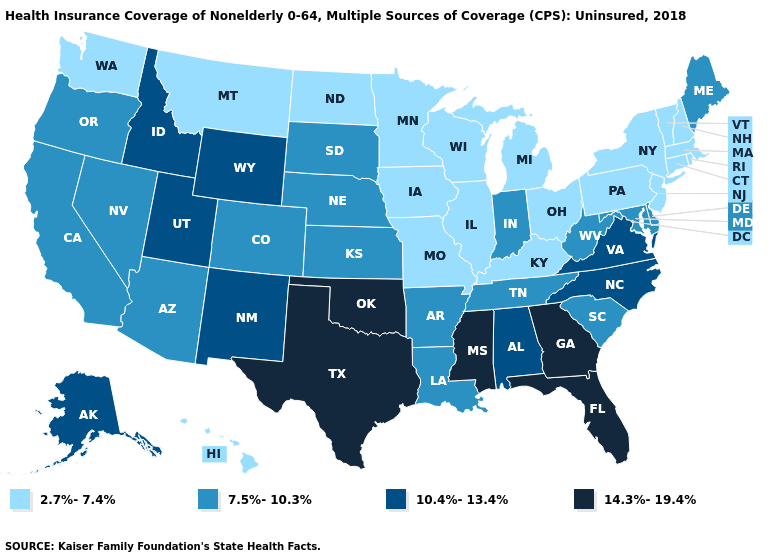What is the value of Rhode Island?
Concise answer only. 2.7%-7.4%. Among the states that border North Carolina , which have the lowest value?
Write a very short answer. South Carolina, Tennessee. Name the states that have a value in the range 2.7%-7.4%?
Answer briefly. Connecticut, Hawaii, Illinois, Iowa, Kentucky, Massachusetts, Michigan, Minnesota, Missouri, Montana, New Hampshire, New Jersey, New York, North Dakota, Ohio, Pennsylvania, Rhode Island, Vermont, Washington, Wisconsin. Does Arizona have the same value as Kansas?
Short answer required. Yes. Does Rhode Island have the lowest value in the USA?
Write a very short answer. Yes. Among the states that border Vermont , which have the lowest value?
Give a very brief answer. Massachusetts, New Hampshire, New York. What is the lowest value in states that border Massachusetts?
Short answer required. 2.7%-7.4%. Among the states that border Oklahoma , which have the lowest value?
Concise answer only. Missouri. What is the value of Ohio?
Be succinct. 2.7%-7.4%. What is the highest value in states that border Delaware?
Short answer required. 7.5%-10.3%. Which states have the lowest value in the USA?
Concise answer only. Connecticut, Hawaii, Illinois, Iowa, Kentucky, Massachusetts, Michigan, Minnesota, Missouri, Montana, New Hampshire, New Jersey, New York, North Dakota, Ohio, Pennsylvania, Rhode Island, Vermont, Washington, Wisconsin. Among the states that border West Virginia , which have the highest value?
Quick response, please. Virginia. Name the states that have a value in the range 10.4%-13.4%?
Be succinct. Alabama, Alaska, Idaho, New Mexico, North Carolina, Utah, Virginia, Wyoming. How many symbols are there in the legend?
Short answer required. 4. What is the value of New Jersey?
Concise answer only. 2.7%-7.4%. 